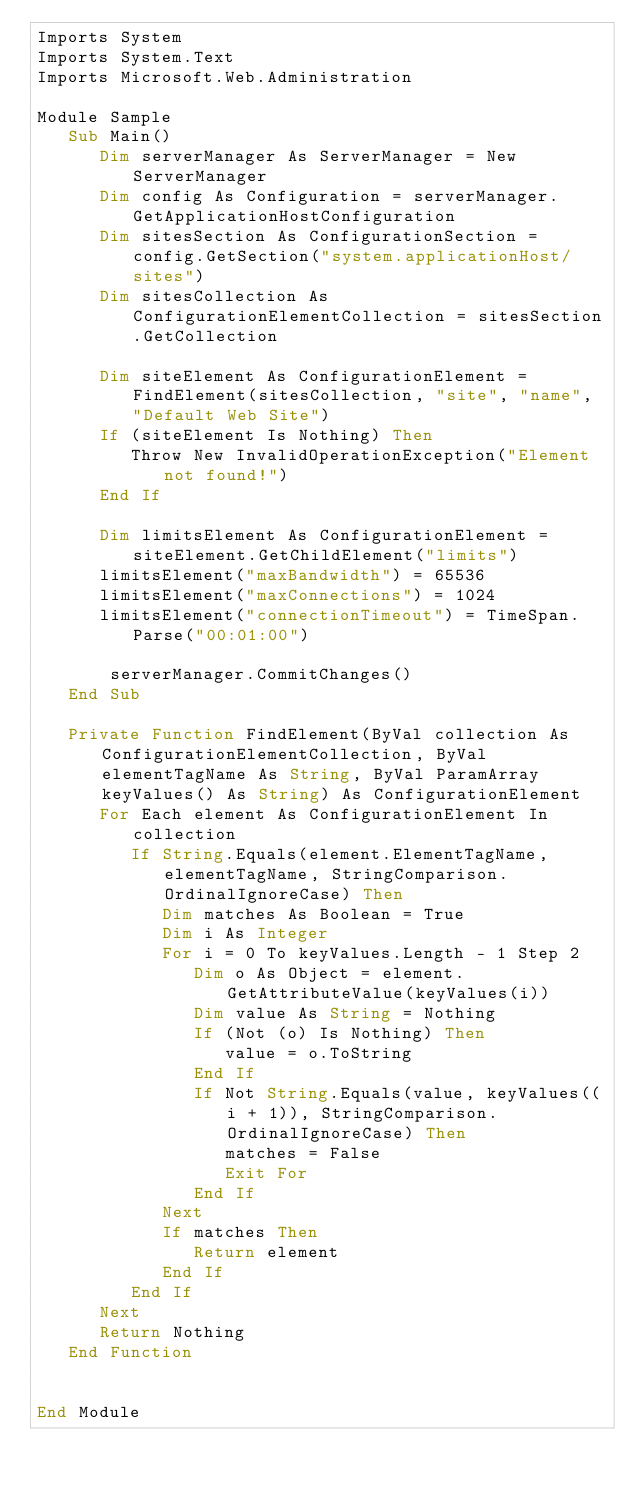Convert code to text. <code><loc_0><loc_0><loc_500><loc_500><_VisualBasic_>Imports System
Imports System.Text
Imports Microsoft.Web.Administration

Module Sample
   Sub Main()
      Dim serverManager As ServerManager = New ServerManager
      Dim config As Configuration = serverManager.GetApplicationHostConfiguration
      Dim sitesSection As ConfigurationSection = config.GetSection("system.applicationHost/sites")
      Dim sitesCollection As ConfigurationElementCollection = sitesSection.GetCollection

      Dim siteElement As ConfigurationElement = FindElement(sitesCollection, "site", "name", "Default Web Site")
      If (siteElement Is Nothing) Then
         Throw New InvalidOperationException("Element not found!")
      End If

      Dim limitsElement As ConfigurationElement = siteElement.GetChildElement("limits")
      limitsElement("maxBandwidth") = 65536
      limitsElement("maxConnections") = 1024
      limitsElement("connectionTimeout") = TimeSpan.Parse("00:01:00")

       serverManager.CommitChanges()
   End Sub

   Private Function FindElement(ByVal collection As ConfigurationElementCollection, ByVal elementTagName As String, ByVal ParamArray keyValues() As String) As ConfigurationElement
      For Each element As ConfigurationElement In collection
         If String.Equals(element.ElementTagName, elementTagName, StringComparison.OrdinalIgnoreCase) Then
            Dim matches As Boolean = True
            Dim i As Integer
            For i = 0 To keyValues.Length - 1 Step 2
               Dim o As Object = element.GetAttributeValue(keyValues(i))
               Dim value As String = Nothing
               If (Not (o) Is Nothing) Then
                  value = o.ToString
               End If
               If Not String.Equals(value, keyValues((i + 1)), StringComparison.OrdinalIgnoreCase) Then
                  matches = False
                  Exit For
               End If
            Next
            If matches Then
               Return element
            End If
         End If
      Next
      Return Nothing
   End Function


End Module</code> 